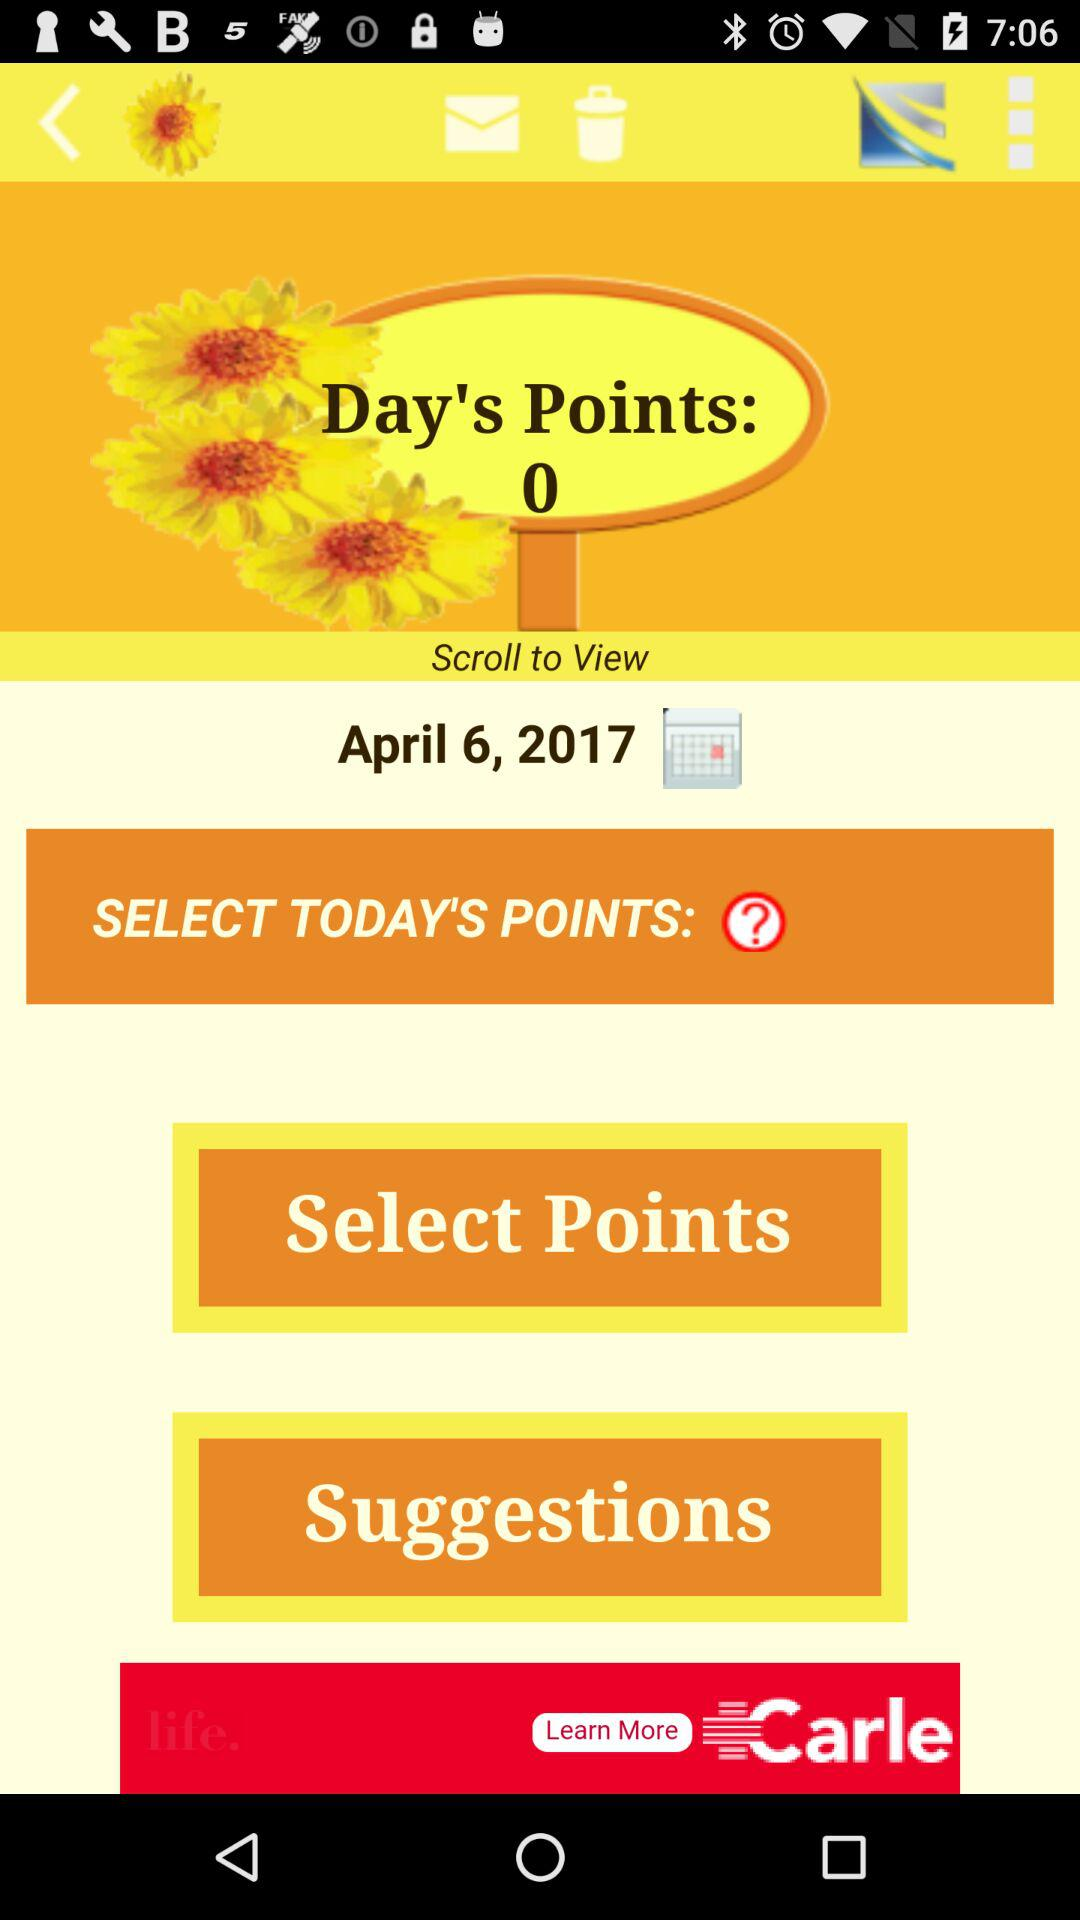What are the total "Day's Points"? The total "Day's Points" are 0. 